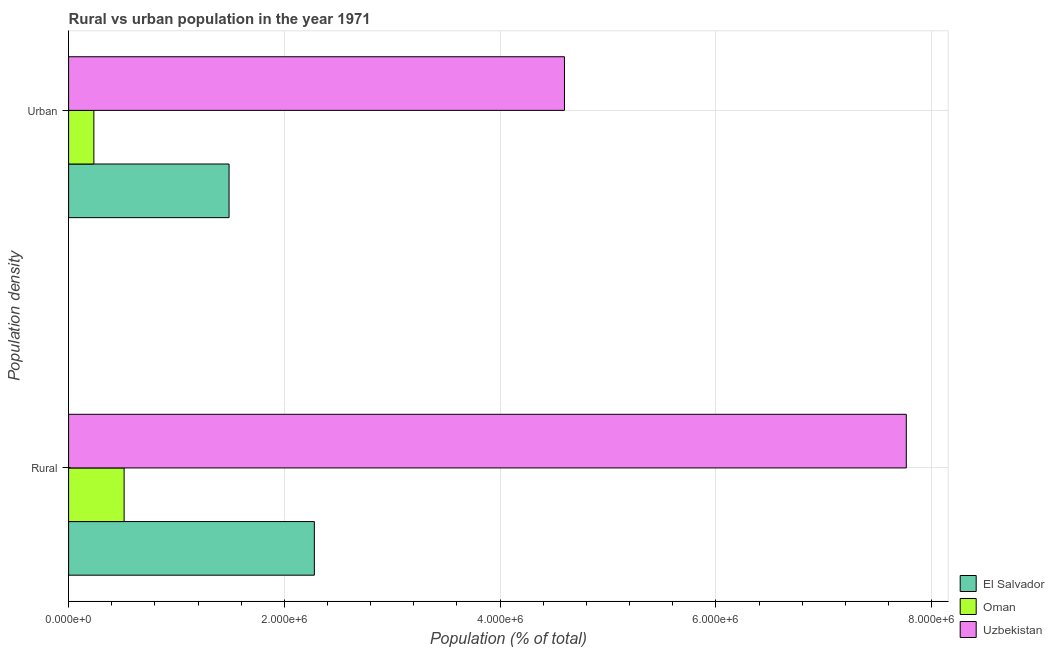Are the number of bars per tick equal to the number of legend labels?
Make the answer very short. Yes. Are the number of bars on each tick of the Y-axis equal?
Make the answer very short. Yes. What is the label of the 2nd group of bars from the top?
Your response must be concise. Rural. What is the urban population density in Oman?
Your answer should be compact. 2.34e+05. Across all countries, what is the maximum rural population density?
Offer a very short reply. 7.76e+06. Across all countries, what is the minimum urban population density?
Provide a short and direct response. 2.34e+05. In which country was the urban population density maximum?
Provide a short and direct response. Uzbekistan. In which country was the urban population density minimum?
Your answer should be very brief. Oman. What is the total rural population density in the graph?
Give a very brief answer. 1.06e+07. What is the difference between the urban population density in Oman and that in El Salvador?
Your response must be concise. -1.25e+06. What is the difference between the urban population density in Uzbekistan and the rural population density in Oman?
Your answer should be compact. 4.08e+06. What is the average rural population density per country?
Offer a very short reply. 3.52e+06. What is the difference between the rural population density and urban population density in Uzbekistan?
Make the answer very short. 3.17e+06. What is the ratio of the urban population density in Oman to that in Uzbekistan?
Your answer should be compact. 0.05. Is the urban population density in El Salvador less than that in Oman?
Your response must be concise. No. What does the 2nd bar from the top in Urban represents?
Keep it short and to the point. Oman. What does the 1st bar from the bottom in Rural represents?
Your answer should be very brief. El Salvador. Are all the bars in the graph horizontal?
Ensure brevity in your answer.  Yes. What is the difference between two consecutive major ticks on the X-axis?
Your answer should be very brief. 2.00e+06. Does the graph contain any zero values?
Your answer should be very brief. No. Does the graph contain grids?
Make the answer very short. Yes. Where does the legend appear in the graph?
Give a very brief answer. Bottom right. How are the legend labels stacked?
Your answer should be compact. Vertical. What is the title of the graph?
Your response must be concise. Rural vs urban population in the year 1971. What is the label or title of the X-axis?
Offer a very short reply. Population (% of total). What is the label or title of the Y-axis?
Offer a very short reply. Population density. What is the Population (% of total) of El Salvador in Rural?
Make the answer very short. 2.28e+06. What is the Population (% of total) in Oman in Rural?
Your answer should be very brief. 5.15e+05. What is the Population (% of total) in Uzbekistan in Rural?
Give a very brief answer. 7.76e+06. What is the Population (% of total) in El Salvador in Urban?
Provide a short and direct response. 1.49e+06. What is the Population (% of total) in Oman in Urban?
Make the answer very short. 2.34e+05. What is the Population (% of total) in Uzbekistan in Urban?
Ensure brevity in your answer.  4.60e+06. Across all Population density, what is the maximum Population (% of total) of El Salvador?
Provide a succinct answer. 2.28e+06. Across all Population density, what is the maximum Population (% of total) of Oman?
Provide a short and direct response. 5.15e+05. Across all Population density, what is the maximum Population (% of total) of Uzbekistan?
Provide a succinct answer. 7.76e+06. Across all Population density, what is the minimum Population (% of total) in El Salvador?
Provide a short and direct response. 1.49e+06. Across all Population density, what is the minimum Population (% of total) of Oman?
Your response must be concise. 2.34e+05. Across all Population density, what is the minimum Population (% of total) in Uzbekistan?
Your answer should be very brief. 4.60e+06. What is the total Population (% of total) in El Salvador in the graph?
Provide a succinct answer. 3.77e+06. What is the total Population (% of total) in Oman in the graph?
Keep it short and to the point. 7.49e+05. What is the total Population (% of total) of Uzbekistan in the graph?
Your answer should be very brief. 1.24e+07. What is the difference between the Population (% of total) in El Salvador in Rural and that in Urban?
Your response must be concise. 7.90e+05. What is the difference between the Population (% of total) in Oman in Rural and that in Urban?
Provide a succinct answer. 2.80e+05. What is the difference between the Population (% of total) of Uzbekistan in Rural and that in Urban?
Your answer should be very brief. 3.17e+06. What is the difference between the Population (% of total) in El Salvador in Rural and the Population (% of total) in Oman in Urban?
Ensure brevity in your answer.  2.04e+06. What is the difference between the Population (% of total) of El Salvador in Rural and the Population (% of total) of Uzbekistan in Urban?
Your answer should be compact. -2.32e+06. What is the difference between the Population (% of total) in Oman in Rural and the Population (% of total) in Uzbekistan in Urban?
Offer a very short reply. -4.08e+06. What is the average Population (% of total) of El Salvador per Population density?
Your answer should be very brief. 1.88e+06. What is the average Population (% of total) of Oman per Population density?
Offer a terse response. 3.74e+05. What is the average Population (% of total) in Uzbekistan per Population density?
Keep it short and to the point. 6.18e+06. What is the difference between the Population (% of total) of El Salvador and Population (% of total) of Oman in Rural?
Your response must be concise. 1.76e+06. What is the difference between the Population (% of total) in El Salvador and Population (% of total) in Uzbekistan in Rural?
Offer a terse response. -5.49e+06. What is the difference between the Population (% of total) in Oman and Population (% of total) in Uzbekistan in Rural?
Offer a very short reply. -7.25e+06. What is the difference between the Population (% of total) in El Salvador and Population (% of total) in Oman in Urban?
Your answer should be very brief. 1.25e+06. What is the difference between the Population (% of total) of El Salvador and Population (% of total) of Uzbekistan in Urban?
Keep it short and to the point. -3.11e+06. What is the difference between the Population (% of total) of Oman and Population (% of total) of Uzbekistan in Urban?
Provide a short and direct response. -4.36e+06. What is the ratio of the Population (% of total) in El Salvador in Rural to that in Urban?
Your answer should be compact. 1.53. What is the ratio of the Population (% of total) of Oman in Rural to that in Urban?
Provide a succinct answer. 2.2. What is the ratio of the Population (% of total) of Uzbekistan in Rural to that in Urban?
Provide a short and direct response. 1.69. What is the difference between the highest and the second highest Population (% of total) in El Salvador?
Ensure brevity in your answer.  7.90e+05. What is the difference between the highest and the second highest Population (% of total) of Oman?
Give a very brief answer. 2.80e+05. What is the difference between the highest and the second highest Population (% of total) of Uzbekistan?
Ensure brevity in your answer.  3.17e+06. What is the difference between the highest and the lowest Population (% of total) in El Salvador?
Provide a succinct answer. 7.90e+05. What is the difference between the highest and the lowest Population (% of total) of Oman?
Your answer should be compact. 2.80e+05. What is the difference between the highest and the lowest Population (% of total) of Uzbekistan?
Offer a terse response. 3.17e+06. 